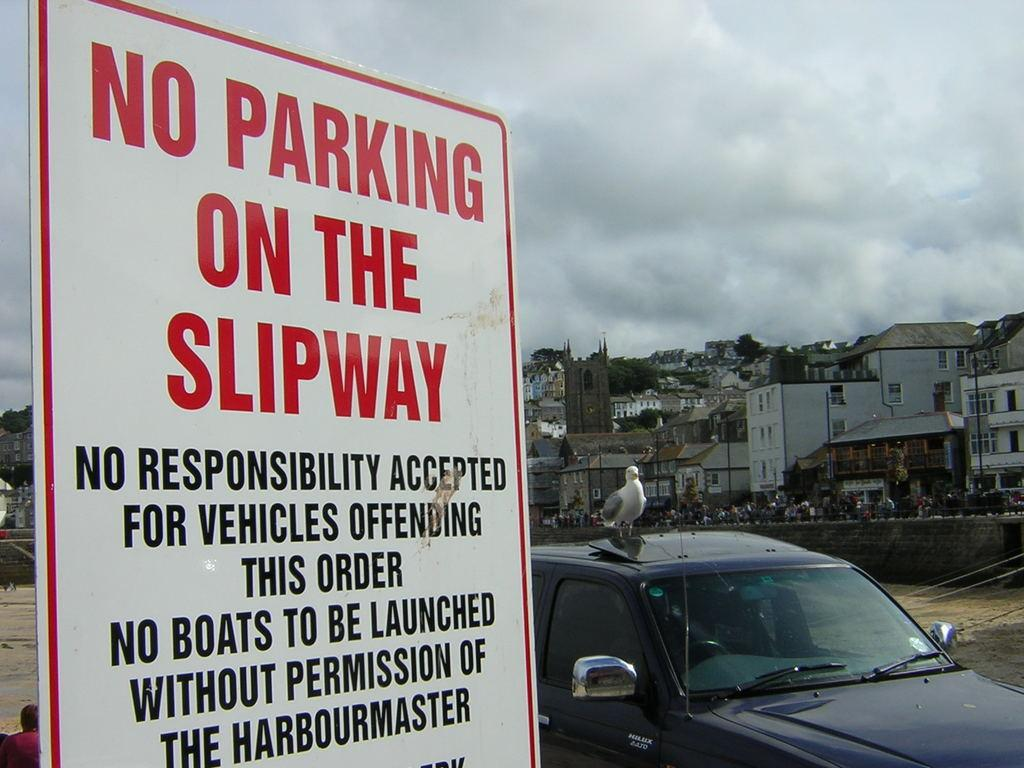What is the main object in the foreground of the image? There is a sign board in the image. What is an interesting detail about the car in the image? There is a bird on a car in the image. What can be seen in the distance behind the car? There are poles, trees, and buildings visible in the background of the image. Are there any people present in the image? Yes, there are people in the background of the image. What type of ray is visible in the image? There is no ray present in the image. How does the memory of the event affect the people in the image? The image does not depict an event or any memories associated with it, so we cannot determine how the memory might affect the people. 